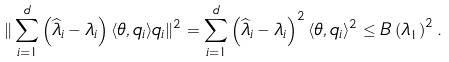Convert formula to latex. <formula><loc_0><loc_0><loc_500><loc_500>\| \sum _ { i = 1 } ^ { d } \left ( \widehat { \lambda } _ { i } - \lambda _ { i } \right ) \langle \theta , q _ { i } \rangle q _ { i } \| ^ { 2 } & = \sum _ { i = 1 } ^ { d } \left ( \widehat { \lambda } _ { i } - \lambda _ { i } \right ) ^ { 2 } \langle \theta , q _ { i } \rangle ^ { 2 } \leq B \left ( \lambda _ { 1 } \right ) ^ { 2 } .</formula> 